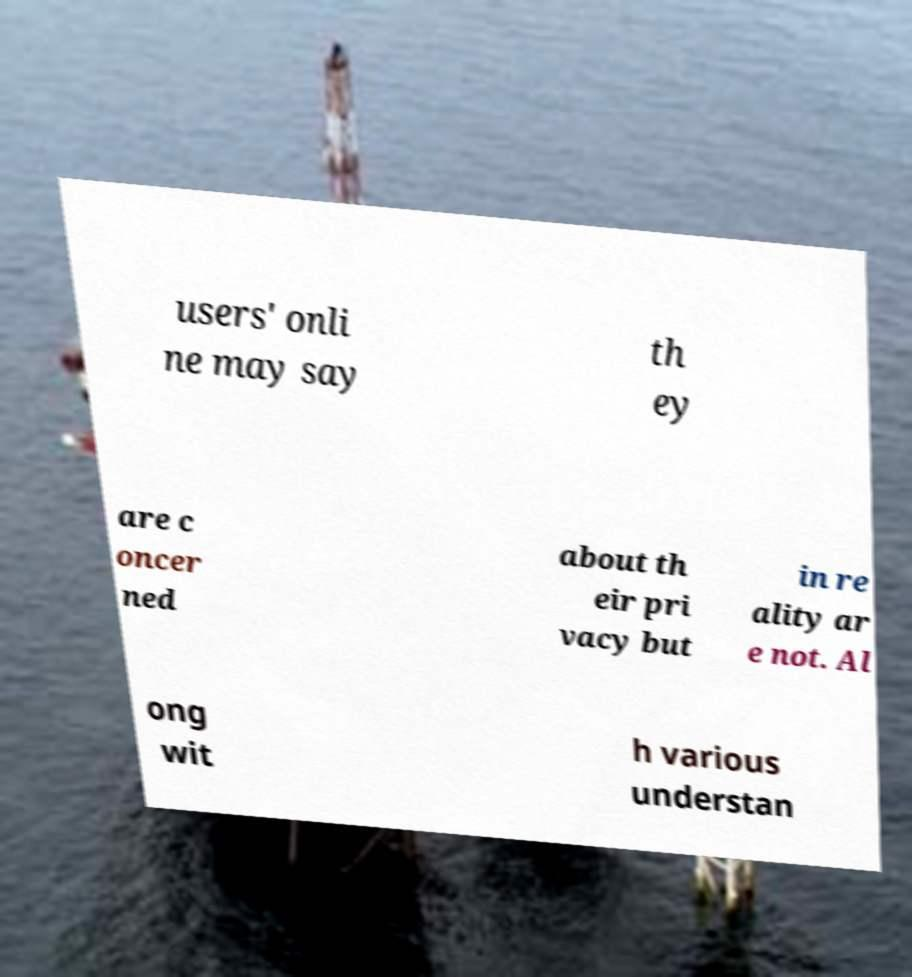Please identify and transcribe the text found in this image. users' onli ne may say th ey are c oncer ned about th eir pri vacy but in re ality ar e not. Al ong wit h various understan 